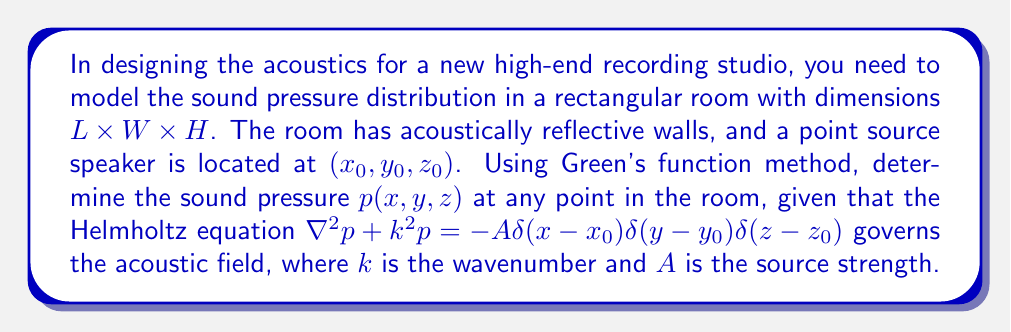Can you answer this question? To solve this boundary value problem using Green's function method, we follow these steps:

1) The Green's function $G(x,y,z|x',y',z')$ for this problem satisfies:
   $$\nabla^2 G + k^2 G = -\delta(x-x')\delta(y-y')\delta(z-z')$$
   with Neumann boundary conditions (reflecting walls).

2) For a rectangular room, the Green's function can be expressed as:
   $$G(x,y,z|x',y',z') = \frac{8}{LWH} \sum_{l,m,n=0}^{\infty} \frac{\cos(\frac{l\pi x}{L})\cos(\frac{m\pi y}{W})\cos(\frac{n\pi z}{H})\cos(\frac{l\pi x'}{L})\cos(\frac{m\pi y'}{W})\cos(\frac{n\pi z'}{H})}{(\frac{l\pi}{L})^2 + (\frac{m\pi}{W})^2 + (\frac{n\pi}{H})^2 - k^2}$$

3) The sound pressure $p(x,y,z)$ is then given by:
   $$p(x,y,z) = A \cdot G(x,y,z|x_0,y_0,z_0)$$

4) Substituting the Green's function:
   $$p(x,y,z) = \frac{8A}{LWH} \sum_{l,m,n=0}^{\infty} \frac{\cos(\frac{l\pi x}{L})\cos(\frac{m\pi y}{W})\cos(\frac{n\pi z}{H})\cos(\frac{l\pi x_0}{L})\cos(\frac{m\pi y_0}{W})\cos(\frac{n\pi z_0}{H})}{(\frac{l\pi}{L})^2 + (\frac{m\pi}{W})^2 + (\frac{n\pi}{H})^2 - k^2}$$

5) This infinite series solution provides the sound pressure at any point $(x,y,z)$ in the room, given the source location $(x_0,y_0,z_0)$, room dimensions, wavenumber $k$, and source strength $A$.
Answer: $$p(x,y,z) = \frac{8A}{LWH} \sum_{l,m,n=0}^{\infty} \frac{\cos(\frac{l\pi x}{L})\cos(\frac{m\pi y}{W})\cos(\frac{n\pi z}{H})\cos(\frac{l\pi x_0}{L})\cos(\frac{m\pi y_0}{W})\cos(\frac{n\pi z_0}{H})}{(\frac{l\pi}{L})^2 + (\frac{m\pi}{W})^2 + (\frac{n\pi}{H})^2 - k^2}$$ 